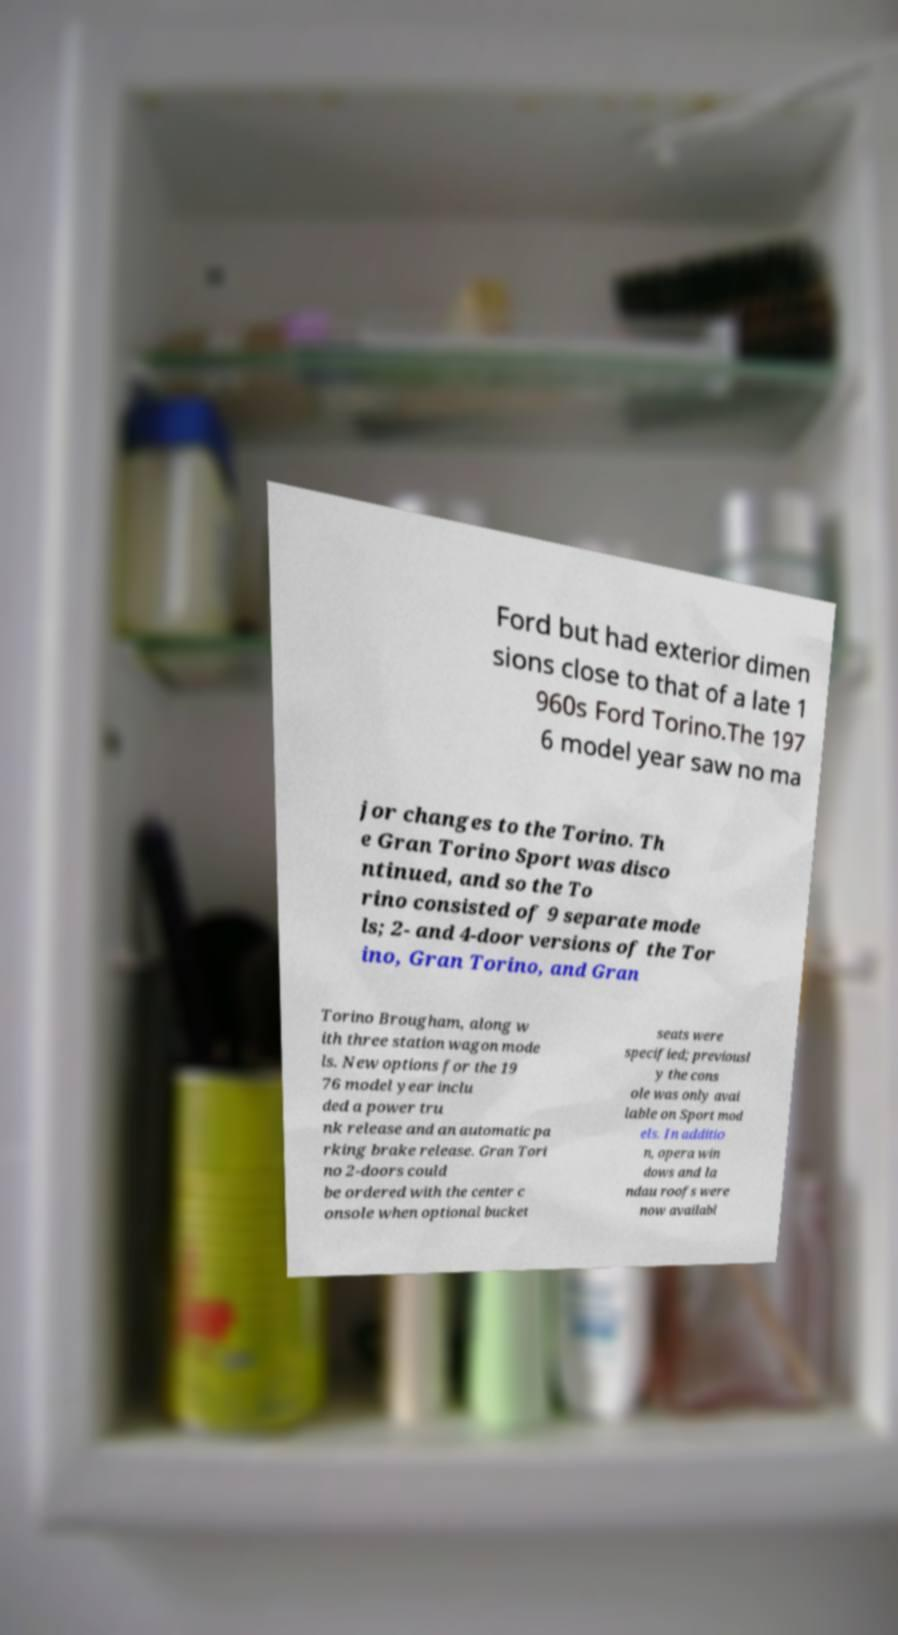I need the written content from this picture converted into text. Can you do that? Ford but had exterior dimen sions close to that of a late 1 960s Ford Torino.The 197 6 model year saw no ma jor changes to the Torino. Th e Gran Torino Sport was disco ntinued, and so the To rino consisted of 9 separate mode ls; 2- and 4-door versions of the Tor ino, Gran Torino, and Gran Torino Brougham, along w ith three station wagon mode ls. New options for the 19 76 model year inclu ded a power tru nk release and an automatic pa rking brake release. Gran Tori no 2-doors could be ordered with the center c onsole when optional bucket seats were specified; previousl y the cons ole was only avai lable on Sport mod els. In additio n, opera win dows and la ndau roofs were now availabl 